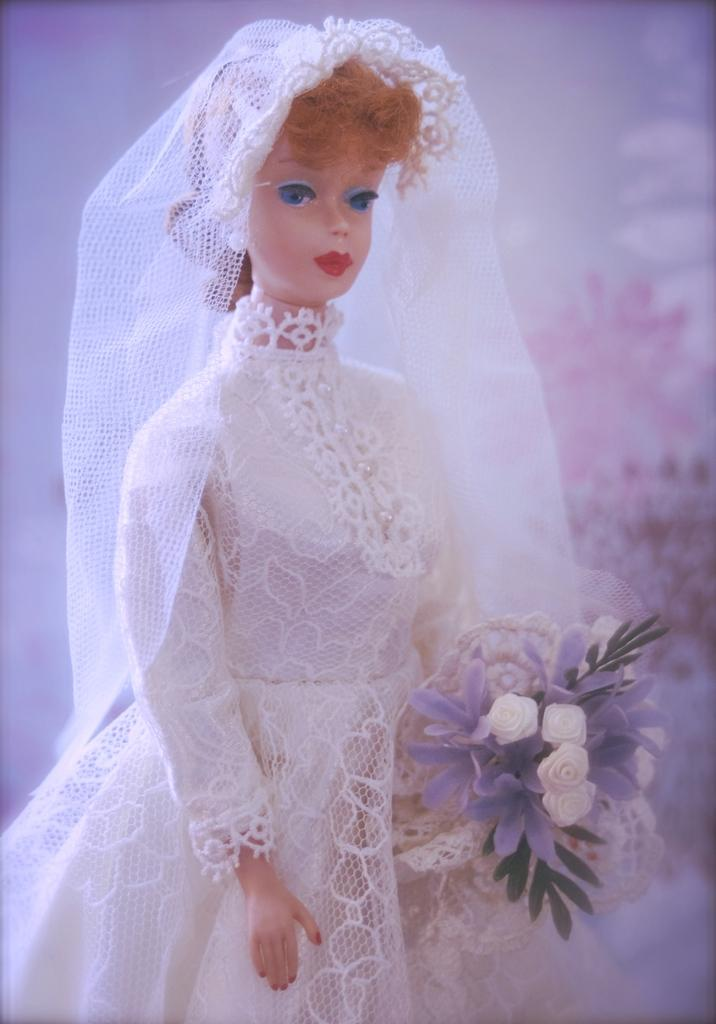What is the main subject of the image? There is a doll in the image. Where is the doll located in the image? The doll is in the center of the image. What is the doll holding in the image? The doll is holding flowers. What type of trucks can be seen in the background of the image? There are no trucks visible in the image; it features a doll holding flowers. Is the doll shown sleeping in the image? The doll is not shown sleeping in the image; it is holding flowers. 